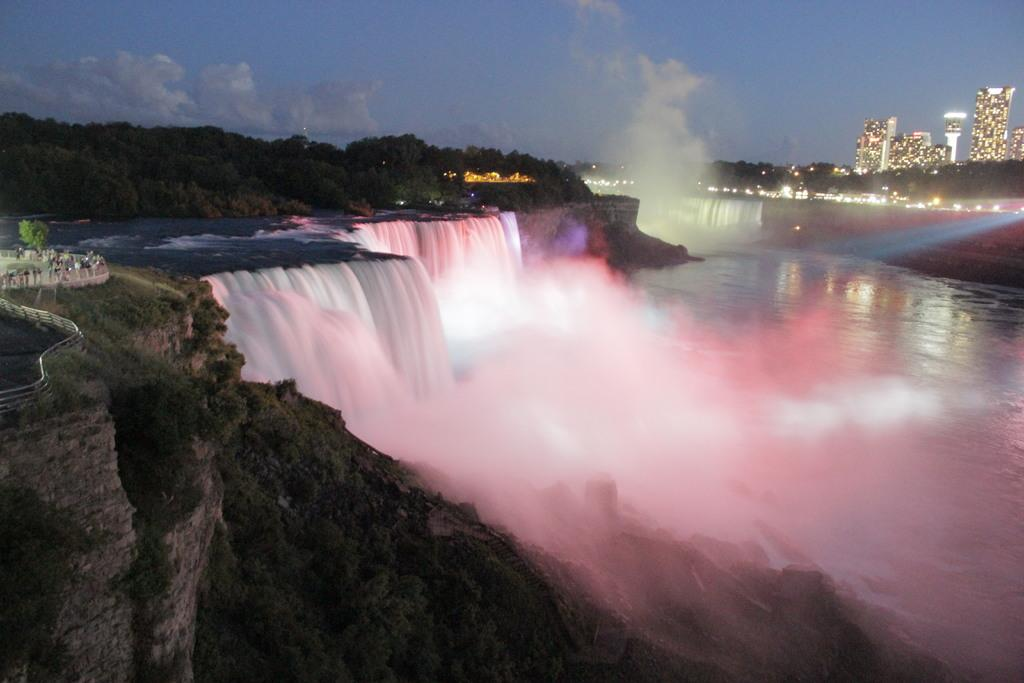What is the main feature in the foreground of the image? There is a waterfall and a cliff in the foreground of the image. What safety feature is present in the foreground of the image? There is a railing in the foreground of the image. What type of vegetation can be seen in the foreground of the image? There are trees in the foreground of the image. What type of structures are visible in the image? There are buildings in the image. What type of illumination is present in the image? There are lights in the image. What is visible in the background of the image? The sky is visible in the image, and there are clouds visible in the sky. How many pies are being served on the cliff in the image? There are no pies present in the image; it features a waterfall, cliff, railing, trees, buildings, lights, sky, and clouds. Can you tell me how the bee is learning to fly in the image? There is no bee present in the image, and therefore no learning or flying activity can be observed. 